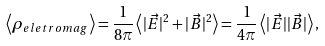Convert formula to latex. <formula><loc_0><loc_0><loc_500><loc_500>\left < \rho _ { e l e t r o m a g } \right > = \frac { 1 } { 8 \pi } \left < | \vec { E } | ^ { 2 } + | \vec { B } | ^ { 2 } \right > = \frac { 1 } { 4 \pi } \left < | \vec { E } | | \vec { B } | \right > ,</formula> 